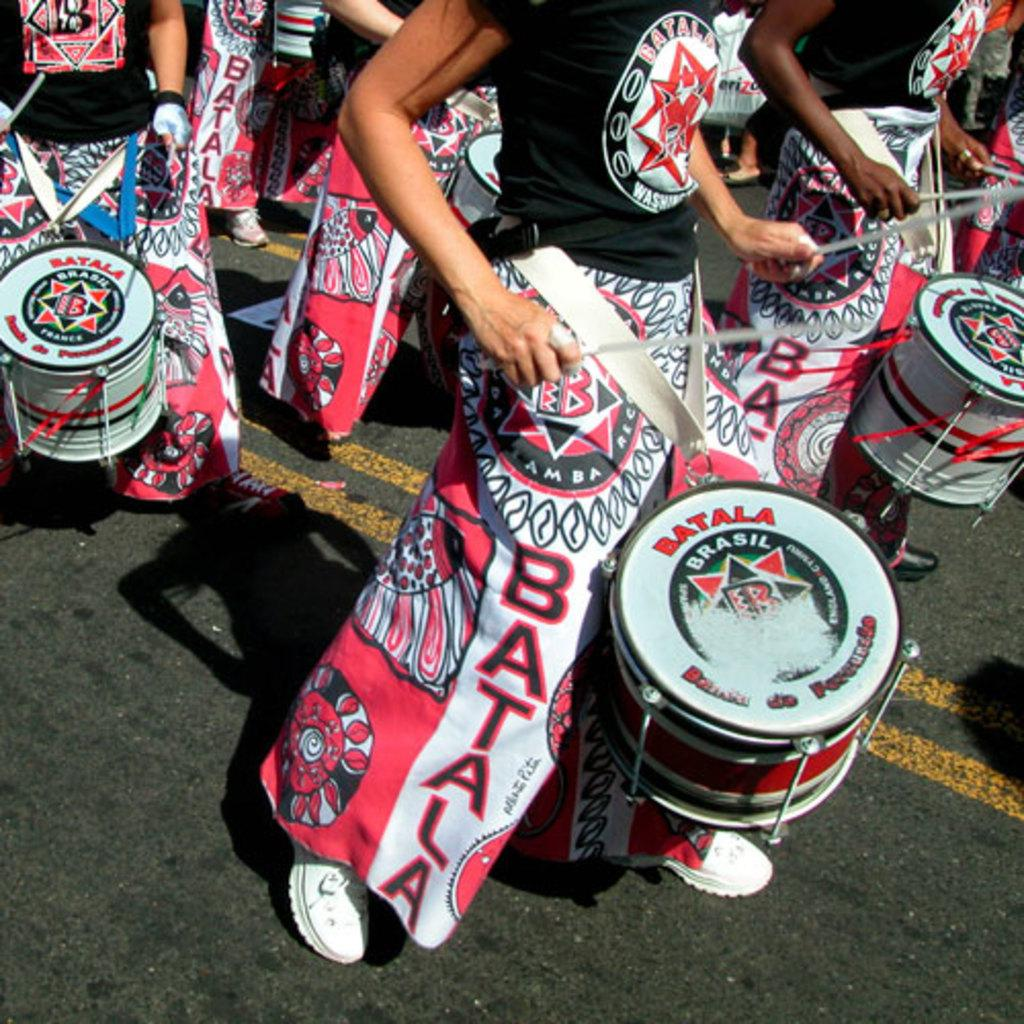<image>
Render a clear and concise summary of the photo. People are drumming in the street and the drums have the word Batala on the top. 